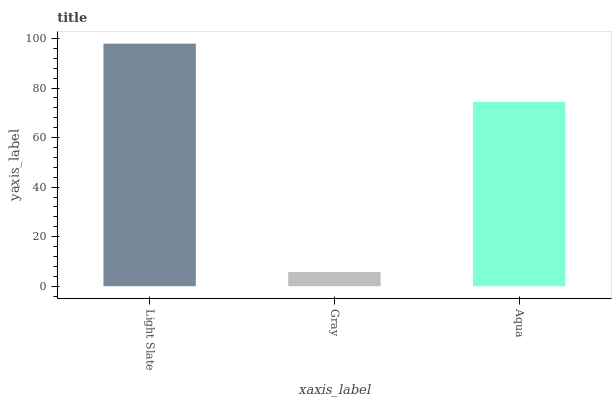Is Gray the minimum?
Answer yes or no. Yes. Is Light Slate the maximum?
Answer yes or no. Yes. Is Aqua the minimum?
Answer yes or no. No. Is Aqua the maximum?
Answer yes or no. No. Is Aqua greater than Gray?
Answer yes or no. Yes. Is Gray less than Aqua?
Answer yes or no. Yes. Is Gray greater than Aqua?
Answer yes or no. No. Is Aqua less than Gray?
Answer yes or no. No. Is Aqua the high median?
Answer yes or no. Yes. Is Aqua the low median?
Answer yes or no. Yes. Is Light Slate the high median?
Answer yes or no. No. Is Light Slate the low median?
Answer yes or no. No. 